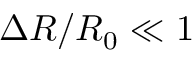<formula> <loc_0><loc_0><loc_500><loc_500>\Delta R / R _ { 0 } \ll 1</formula> 